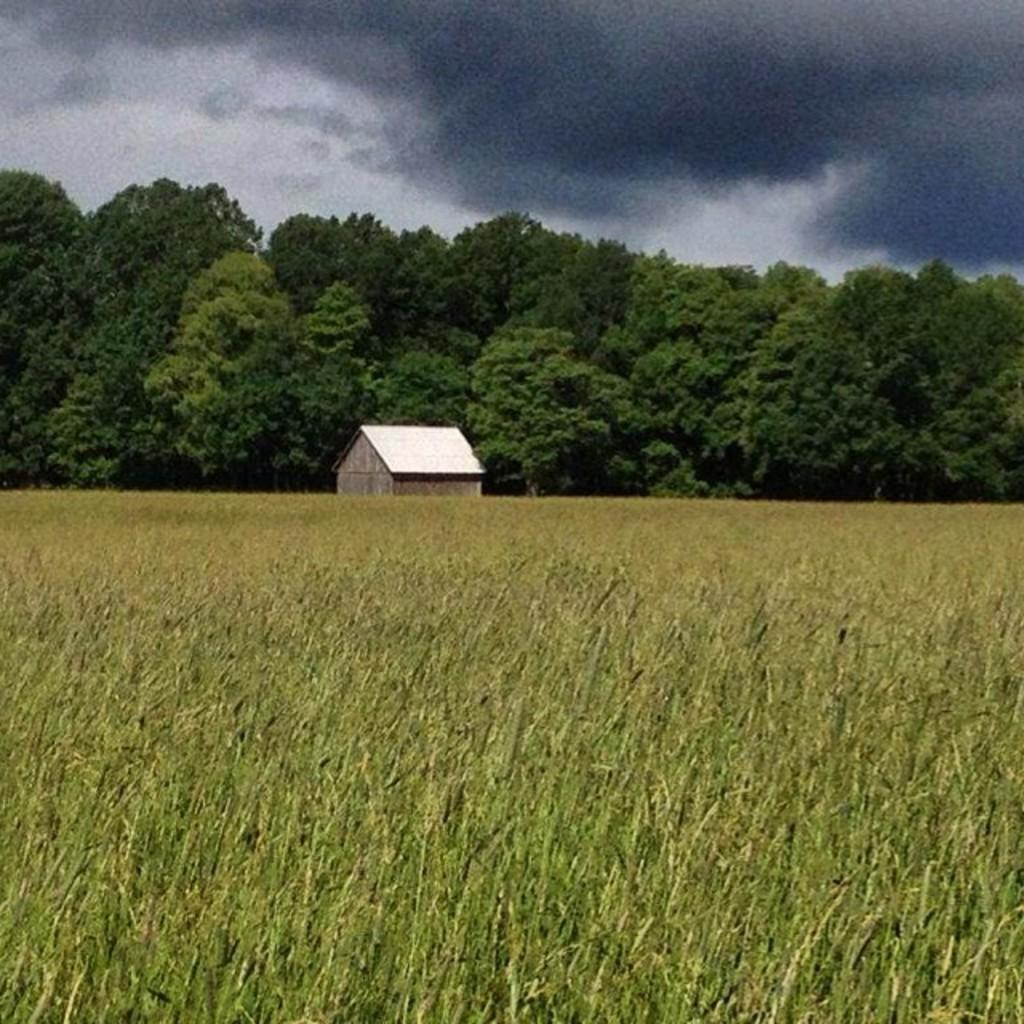What type of vegetation is at the bottom of the image? There is grass at the bottom of the image. What structure is located in the middle of the image? There is a house in the middle of the image. What can be seen in the background of the image? There are trees in the background of the image. What is visible at the top of the image? The sky is visible at the top of the image. What can be observed in the sky? Clouds are present in the sky. Where is the hen located in the image? There is no hen present in the image. What type of rail can be seen supporting the house in the image? There is no rail present in the image; the house is not supported by any rail. 